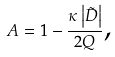Convert formula to latex. <formula><loc_0><loc_0><loc_500><loc_500>A = 1 - \frac { \kappa \left | \tilde { D } \right | } { 2 Q } \text {,}</formula> 